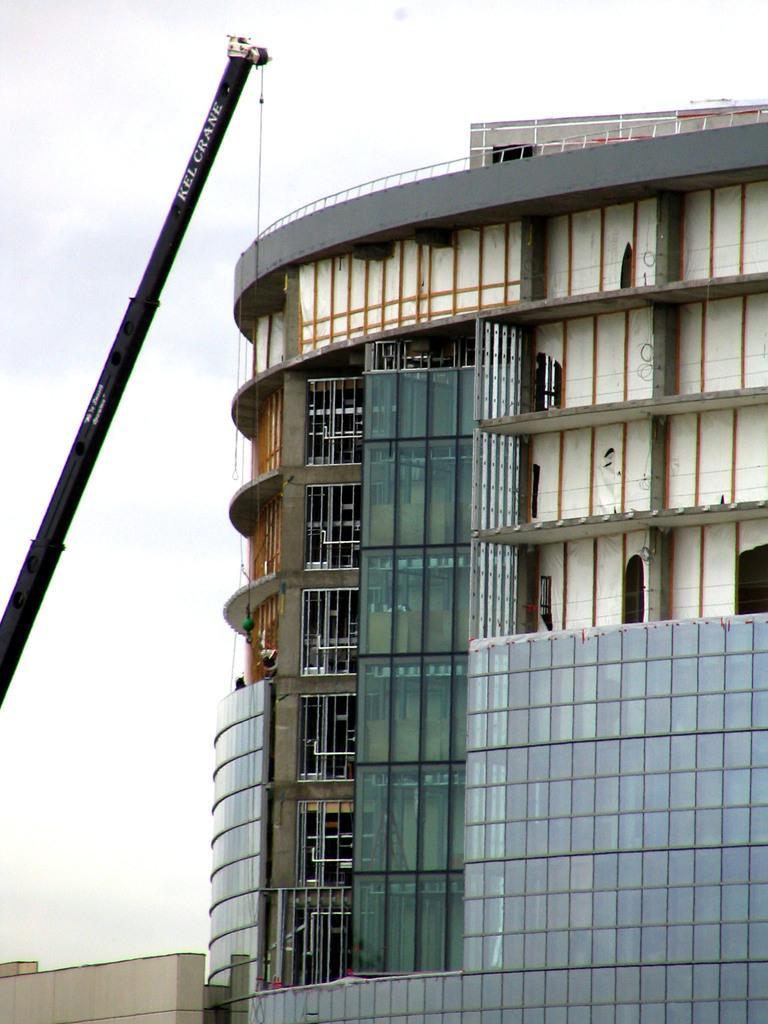Can you describe this image briefly? In this image, we can see a building. There is a crane on the left side of the image. At the top of the image, we can see the sky. 